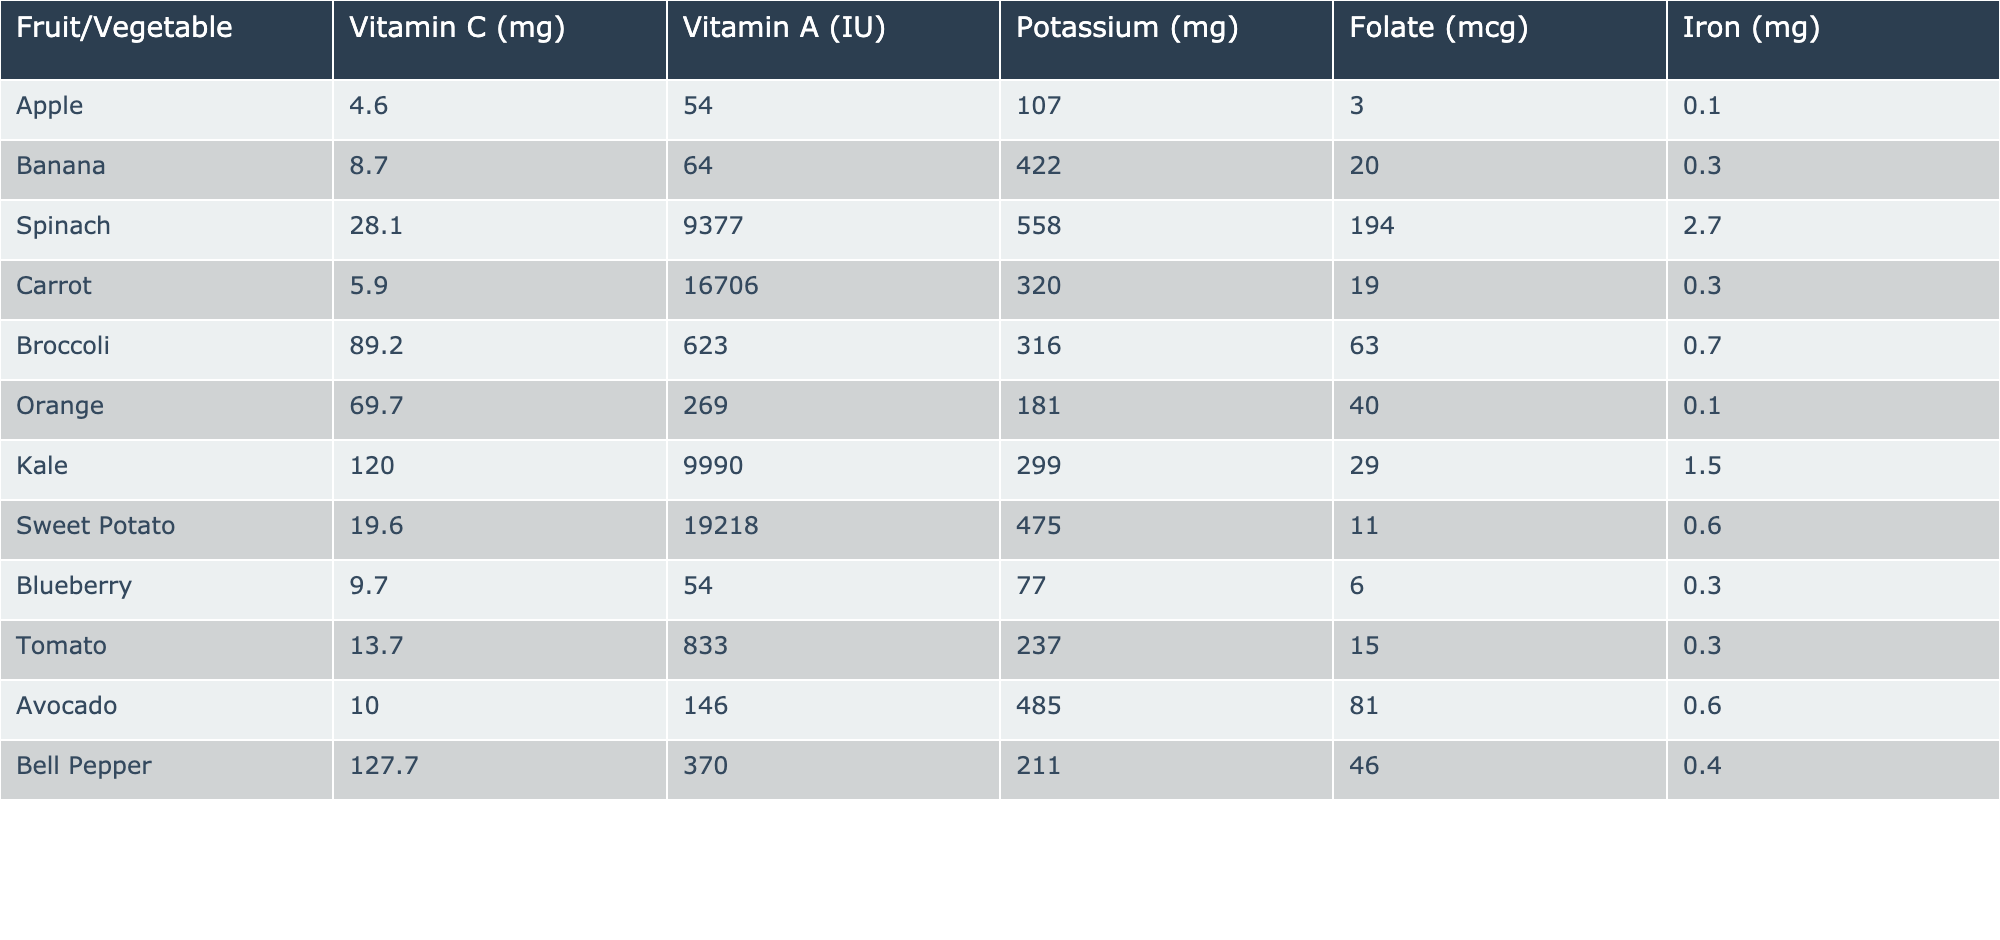What is the Vitamin C content in Kale? The table clearly lists the Vitamin C content for Kale, which is stated to be 120 mg.
Answer: 120 mg Which fruit has the highest Iron content? By comparing the Iron content across all fruits and vegetables, Spinach has the highest Iron content at 2.7 mg.
Answer: Spinach What is the average Potassium content of Orange and Banana? The Potassium content for Orange is 181 mg and for Banana is 422 mg. The average is calculated as (181 + 422) / 2 = 301.5 mg.
Answer: 301.5 mg Is there any fruit among the listed items with a Folate content greater than 60 mcg? Checking the Folate content, Spinach has 194 mcg, which is greater than 60 mcg, making the statement true.
Answer: Yes Which vegetable has the lowest Vitamin C content? Comparing the Vitamin C content, the Apple has the lowest at 4.6 mg compared to other items listed in the table.
Answer: Apple If we combine the Vitamin C from Orange and Broccoli, what is the total? The Vitamin C for Orange is 69.7 mg and for Broccoli is 89.2 mg, so the total is 69.7 + 89.2 = 158.9 mg.
Answer: 158.9 mg Which fruit has a higher Vitamin A content, Tomato or Avocado? The table shows that Tomato has 833 IU of Vitamin A while Avocado has 146 IU. Therefore, Tomato has a higher content.
Answer: Tomato What is the difference in Folate content between Spinach and Sweet Potato? Spinach has 194 mcg of Folate and Sweet Potato has 11 mcg. The difference is 194 - 11 = 183 mcg.
Answer: 183 mcg Is the Potassium content in Bell Pepper greater than that in Tomato? The Potassium in Bell Pepper is 211 mg, and in Tomato, it is 237 mg. Since 211 mg is less than 237 mg, the statement is false.
Answer: No 